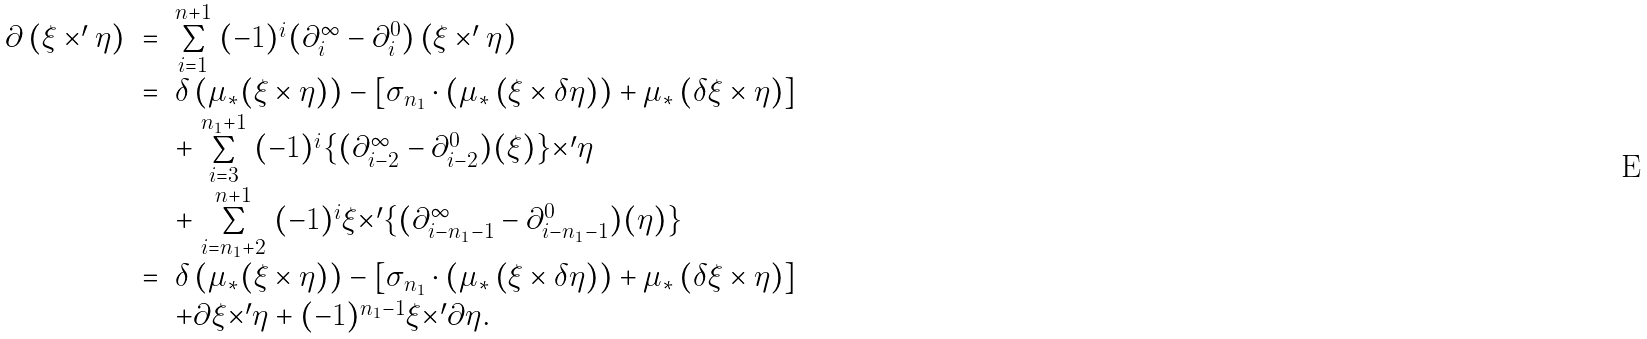<formula> <loc_0><loc_0><loc_500><loc_500>\begin{array} { l l l } \partial \left ( \xi \times ^ { \prime } \eta \right ) & = & \stackrel { n + 1 } { \underset { i = 1 } \sum } ( - 1 ) ^ { i } ( \partial _ { i } ^ { \infty } - \partial _ { i } ^ { 0 } ) \left ( \xi \times ^ { \prime } \eta \right ) \\ & = & \delta \left ( \mu _ { * } ( \xi \times \eta ) \right ) - [ \sigma _ { n _ { 1 } } \cdot \left ( \mu _ { * } \left ( \xi \times \delta \eta \right ) \right ) + \mu _ { * } \left ( \delta \xi \times \eta \right ) ] \\ & & + \stackrel { n _ { 1 } + 1 } { \underset { i = 3 } \sum } ( - 1 ) ^ { i } \{ ( \partial _ { i - 2 } ^ { \infty } - \partial ^ { 0 } _ { i - 2 } ) ( \xi ) \} { \times } ^ { \prime } \eta \\ & & + \stackrel { n + 1 } { \underset { i = n _ { 1 } + 2 } \sum } ( - 1 ) ^ { i } \xi { \times } ^ { \prime } \{ ( \partial _ { i - n _ { 1 } - 1 } ^ { \infty } - \partial ^ { 0 } _ { i - n _ { 1 } - 1 } ) ( \eta ) \} \\ & = & \delta \left ( \mu _ { * } ( \xi \times \eta ) \right ) - [ \sigma _ { n _ { 1 } } \cdot \left ( \mu _ { * } \left ( \xi \times \delta \eta \right ) \right ) + \mu _ { * } \left ( \delta \xi \times \eta \right ) ] \\ & & + \partial \xi { \times } ^ { \prime } \eta + ( - 1 ) ^ { n _ { 1 } - 1 } \xi { \times } ^ { \prime } \partial \eta . \end{array}</formula> 